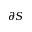Convert formula to latex. <formula><loc_0><loc_0><loc_500><loc_500>\partial S</formula> 